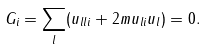<formula> <loc_0><loc_0><loc_500><loc_500>G _ { i } = \sum _ { l } ( u _ { l l i } + 2 m u _ { l i } u _ { l } ) = 0 .</formula> 